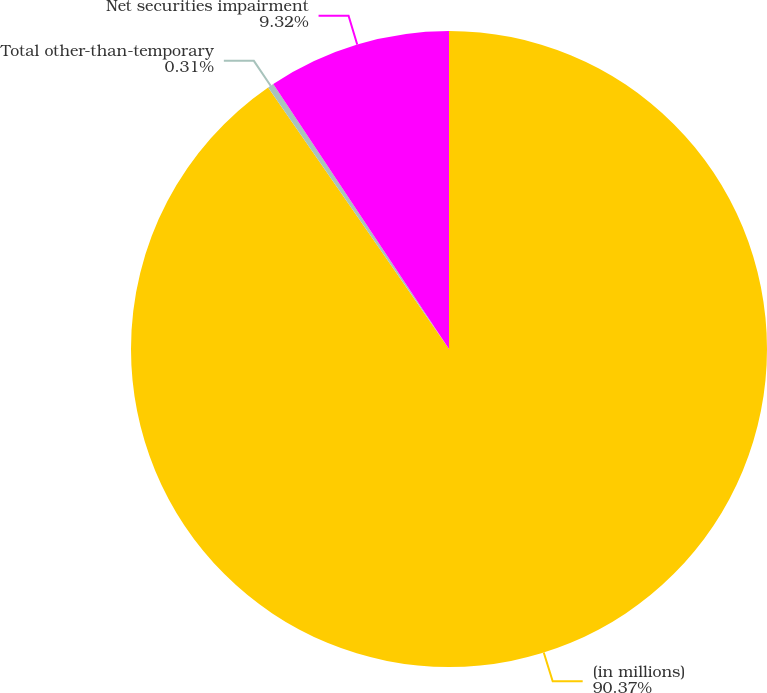Convert chart to OTSL. <chart><loc_0><loc_0><loc_500><loc_500><pie_chart><fcel>(in millions)<fcel>Total other-than-temporary<fcel>Net securities impairment<nl><fcel>90.37%<fcel>0.31%<fcel>9.32%<nl></chart> 